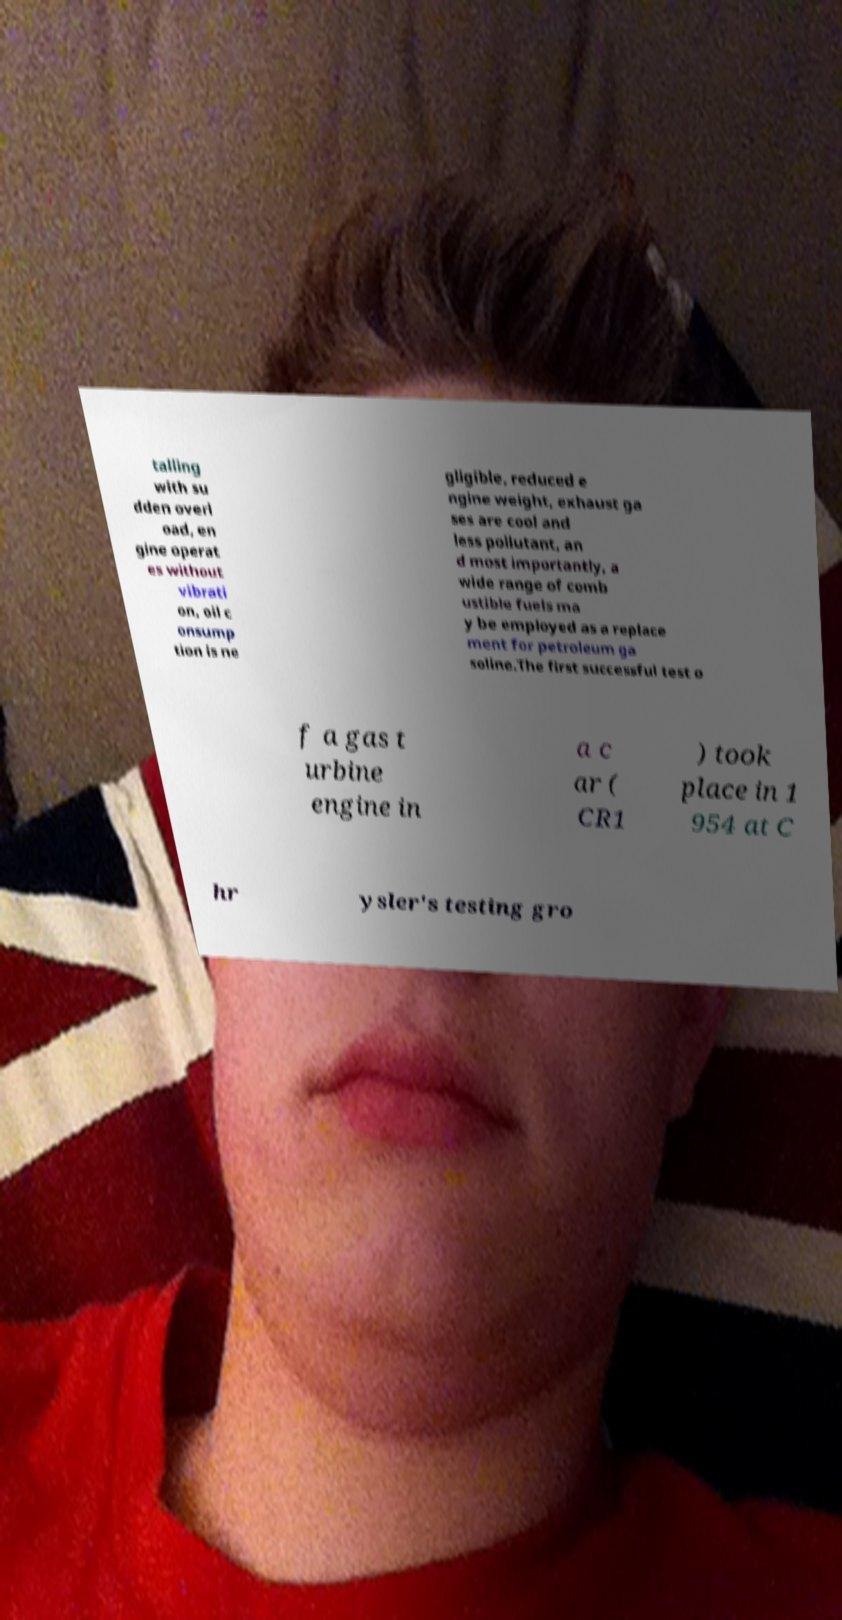Please read and relay the text visible in this image. What does it say? talling with su dden overl oad, en gine operat es without vibrati on, oil c onsump tion is ne gligible, reduced e ngine weight, exhaust ga ses are cool and less pollutant, an d most importantly, a wide range of comb ustible fuels ma y be employed as a replace ment for petroleum ga soline.The first successful test o f a gas t urbine engine in a c ar ( CR1 ) took place in 1 954 at C hr ysler's testing gro 